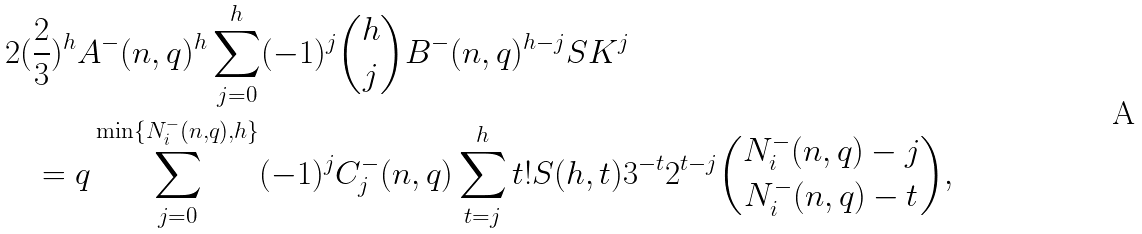<formula> <loc_0><loc_0><loc_500><loc_500>2 ( & \frac { 2 } { 3 } ) ^ { h } A ^ { - } ( n , q ) ^ { h } \sum ^ { h } _ { j = 0 } ( - 1 ) ^ { j } \binom { h } { j } B ^ { - } ( n , q ) ^ { h - j } S K ^ { j } \\ & = q \sum ^ { \min \{ N ^ { - } _ { i } ( n , q ) , h \} } _ { j = 0 } ( - 1 ) ^ { j } C ^ { - } _ { j } ( n , q ) \sum ^ { h } _ { t = j } t ! S ( h , t ) 3 ^ { - t } 2 ^ { t - j } \binom { N ^ { - } _ { i } ( n , q ) - j } { N ^ { - } _ { i } ( n , q ) - t } ,</formula> 